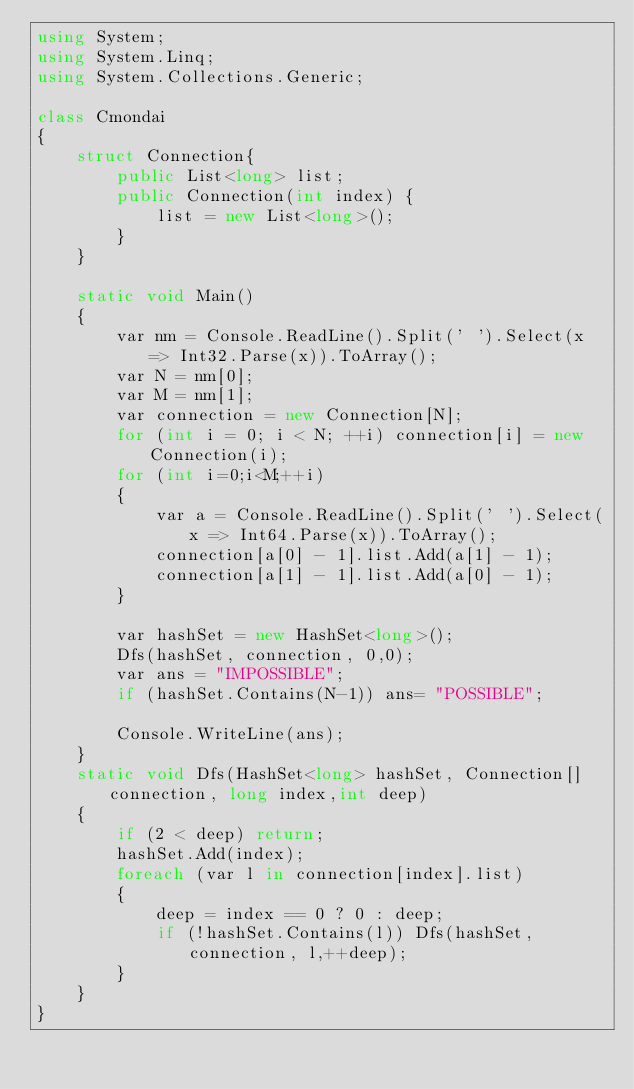<code> <loc_0><loc_0><loc_500><loc_500><_C#_>using System;
using System.Linq;
using System.Collections.Generic;

class Cmondai
{
    struct Connection{
        public List<long> list;
        public Connection(int index) {
            list = new List<long>();
        }
    }

    static void Main()
    {
        var nm = Console.ReadLine().Split(' ').Select(x => Int32.Parse(x)).ToArray();
        var N = nm[0];
        var M = nm[1];
        var connection = new Connection[N];
        for (int i = 0; i < N; ++i) connection[i] = new Connection(i);
        for (int i=0;i<M;++i)
        {
            var a = Console.ReadLine().Split(' ').Select(x => Int64.Parse(x)).ToArray();
            connection[a[0] - 1].list.Add(a[1] - 1);
            connection[a[1] - 1].list.Add(a[0] - 1);
        }

        var hashSet = new HashSet<long>();
        Dfs(hashSet, connection, 0,0);
        var ans = "IMPOSSIBLE";
        if (hashSet.Contains(N-1)) ans= "POSSIBLE";

        Console.WriteLine(ans);
    }
    static void Dfs(HashSet<long> hashSet, Connection[] connection, long index,int deep)
    {
        if (2 < deep) return;
        hashSet.Add(index);
        foreach (var l in connection[index].list)
        {
            deep = index == 0 ? 0 : deep;
            if (!hashSet.Contains(l)) Dfs(hashSet, connection, l,++deep);
        }
    }
}</code> 